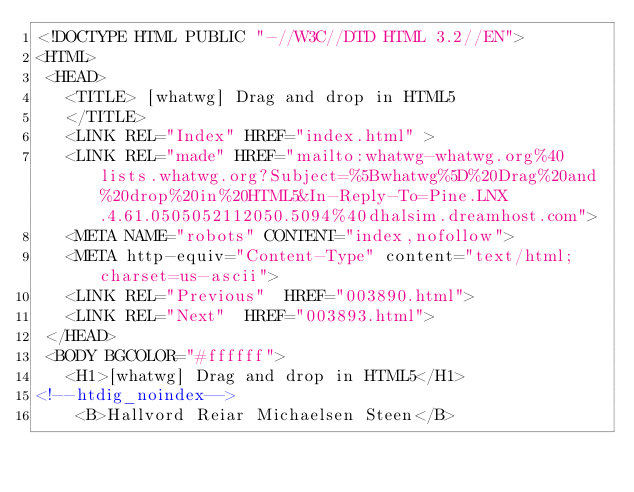<code> <loc_0><loc_0><loc_500><loc_500><_HTML_><!DOCTYPE HTML PUBLIC "-//W3C//DTD HTML 3.2//EN">
<HTML>
 <HEAD>
   <TITLE> [whatwg] Drag and drop in HTML5
   </TITLE>
   <LINK REL="Index" HREF="index.html" >
   <LINK REL="made" HREF="mailto:whatwg-whatwg.org%40lists.whatwg.org?Subject=%5Bwhatwg%5D%20Drag%20and%20drop%20in%20HTML5&In-Reply-To=Pine.LNX.4.61.0505052112050.5094%40dhalsim.dreamhost.com">
   <META NAME="robots" CONTENT="index,nofollow">
   <META http-equiv="Content-Type" content="text/html; charset=us-ascii">
   <LINK REL="Previous"  HREF="003890.html">
   <LINK REL="Next"  HREF="003893.html">
 </HEAD>
 <BODY BGCOLOR="#ffffff">
   <H1>[whatwg] Drag and drop in HTML5</H1>
<!--htdig_noindex-->
    <B>Hallvord Reiar Michaelsen Steen</B> </code> 